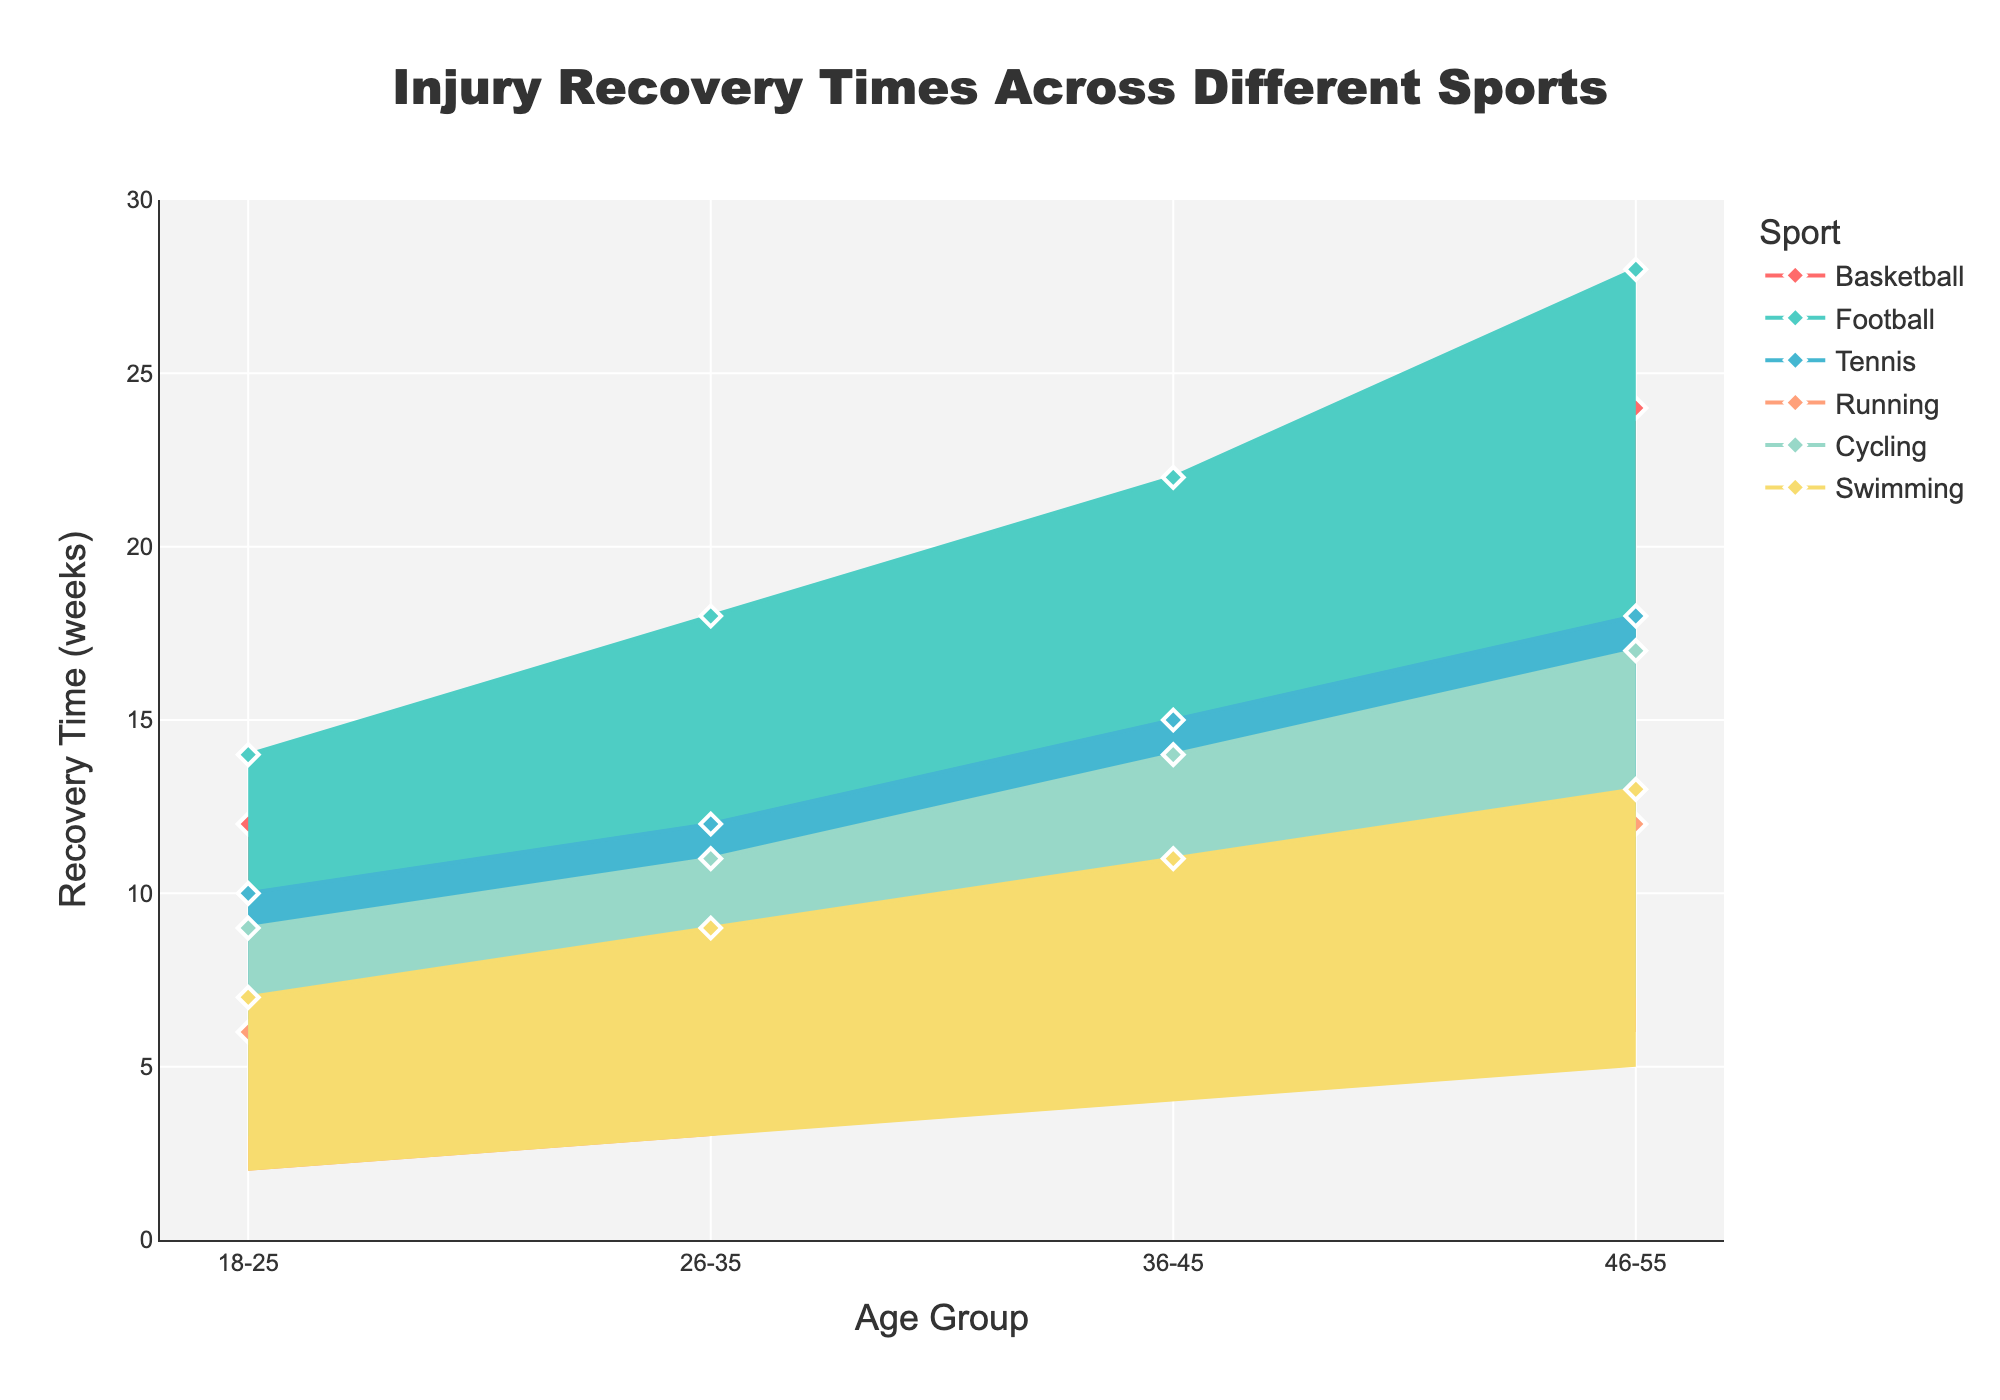What's the title of the chart? The title is usually placed at the top of the chart. It provides a summary of what the chart represents. In this case, the title is "Injury Recovery Times Across Different Sports".
Answer: Injury Recovery Times Across Different Sports What sport has the shortest minimum recovery time for the age group 18-25? By examining the different sports and their minimum recovery times for the age group 18-25, Running has the shortest minimum recovery time of 2 weeks.
Answer: Running For the age group 46-55, which sport has the highest maximum recovery time and what is it? By comparing the maximum recovery times for each sport in the age group 46-55, Football has the highest maximum recovery time of 28 weeks.
Answer: Football, 28 weeks How does the recovery time range change for Basketball from age group 18-25 to 46-55? In age group 18-25, the recovery time ranges from 4 to 12 weeks. In age group 46-55, it ranges from 10 to 24 weeks. The range increases as the minimum and maximum recovery times both go up.
Answer: It increases Which sport shows the least increase in maximum recovery time from age group 18-25 to 46-55? By comparing the maximum recovery times for each sport from 18-25 to 46-55, Swimming shows the least increase from 7 to 13 weeks. The difference is only 6 weeks.
Answer: Swimming Compare the maximum recovery times for Tennis and Cycling in the age group 36-45. Which one is higher? For the age group 36-45, Tennis has a maximum recovery time of 15 weeks, while Cycling has 14 weeks. Therefore, Tennis has a higher maximum recovery time.
Answer: Tennis What is the range of recovery times for Running in the age group 26-35? For Running in the age group 26-35, the minimum recovery time is 3 weeks and the maximum recovery time is 8 weeks. The range is the difference between these two values, which is 5 weeks.
Answer: 5 weeks Between Basketball and Football, which sport has a higher increase in minimum recovery time from age group 36-45 to 46-55? For ages 36-45, Basketball has a minimum recovery time of 8 weeks, increasing to 10 weeks for ages 46-55. Football has a minimum recovery time of 9 weeks, increasing to 11 weeks for ages 46-55. The increase for both is 2 weeks, so they are equal.
Answer: Equal 